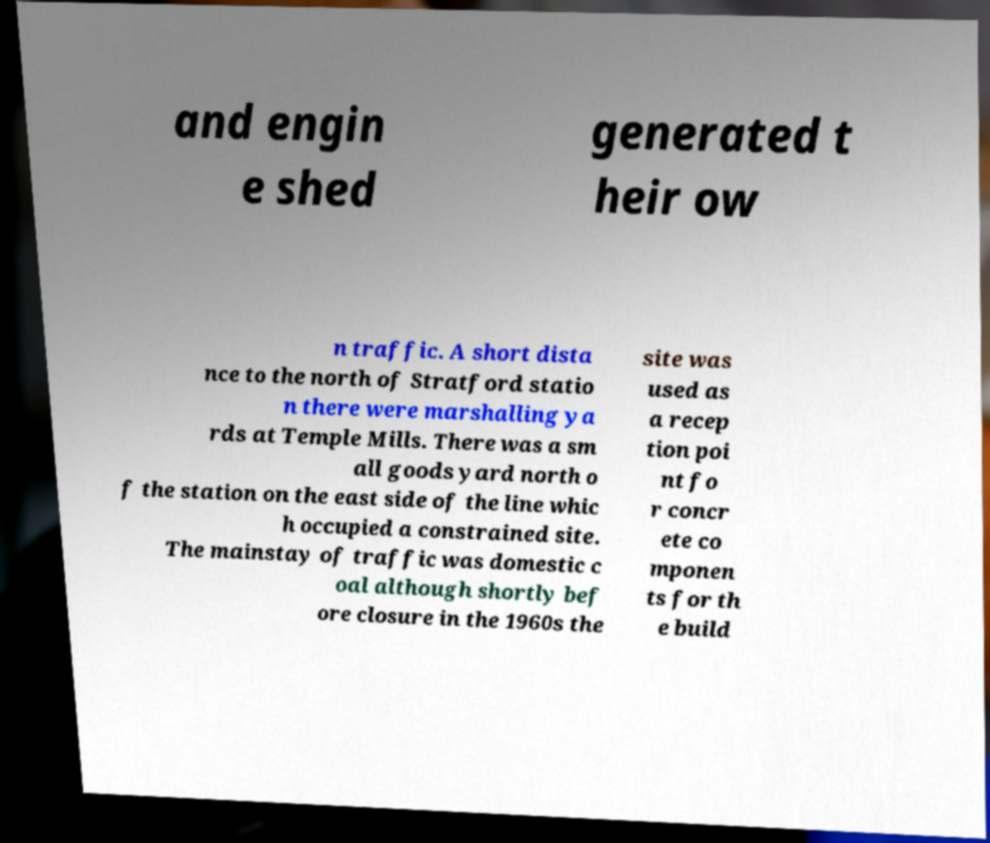Please read and relay the text visible in this image. What does it say? and engin e shed generated t heir ow n traffic. A short dista nce to the north of Stratford statio n there were marshalling ya rds at Temple Mills. There was a sm all goods yard north o f the station on the east side of the line whic h occupied a constrained site. The mainstay of traffic was domestic c oal although shortly bef ore closure in the 1960s the site was used as a recep tion poi nt fo r concr ete co mponen ts for th e build 